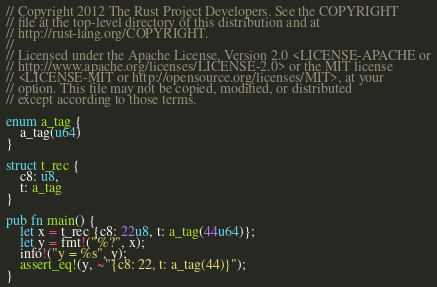<code> <loc_0><loc_0><loc_500><loc_500><_Rust_>// Copyright 2012 The Rust Project Developers. See the COPYRIGHT
// file at the top-level directory of this distribution and at
// http://rust-lang.org/COPYRIGHT.
//
// Licensed under the Apache License, Version 2.0 <LICENSE-APACHE or
// http://www.apache.org/licenses/LICENSE-2.0> or the MIT license
// <LICENSE-MIT or http://opensource.org/licenses/MIT>, at your
// option. This file may not be copied, modified, or distributed
// except according to those terms.

enum a_tag {
    a_tag(u64)
}

struct t_rec {
    c8: u8,
    t: a_tag
}

pub fn main() {
    let x = t_rec {c8: 22u8, t: a_tag(44u64)};
    let y = fmt!("%?", x);
    info!("y = %s", y);
    assert_eq!(y, ~"{c8: 22, t: a_tag(44)}");
}
</code> 